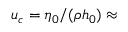<formula> <loc_0><loc_0><loc_500><loc_500>u _ { c } = \eta _ { 0 } / ( \rho h _ { 0 } ) \approx</formula> 